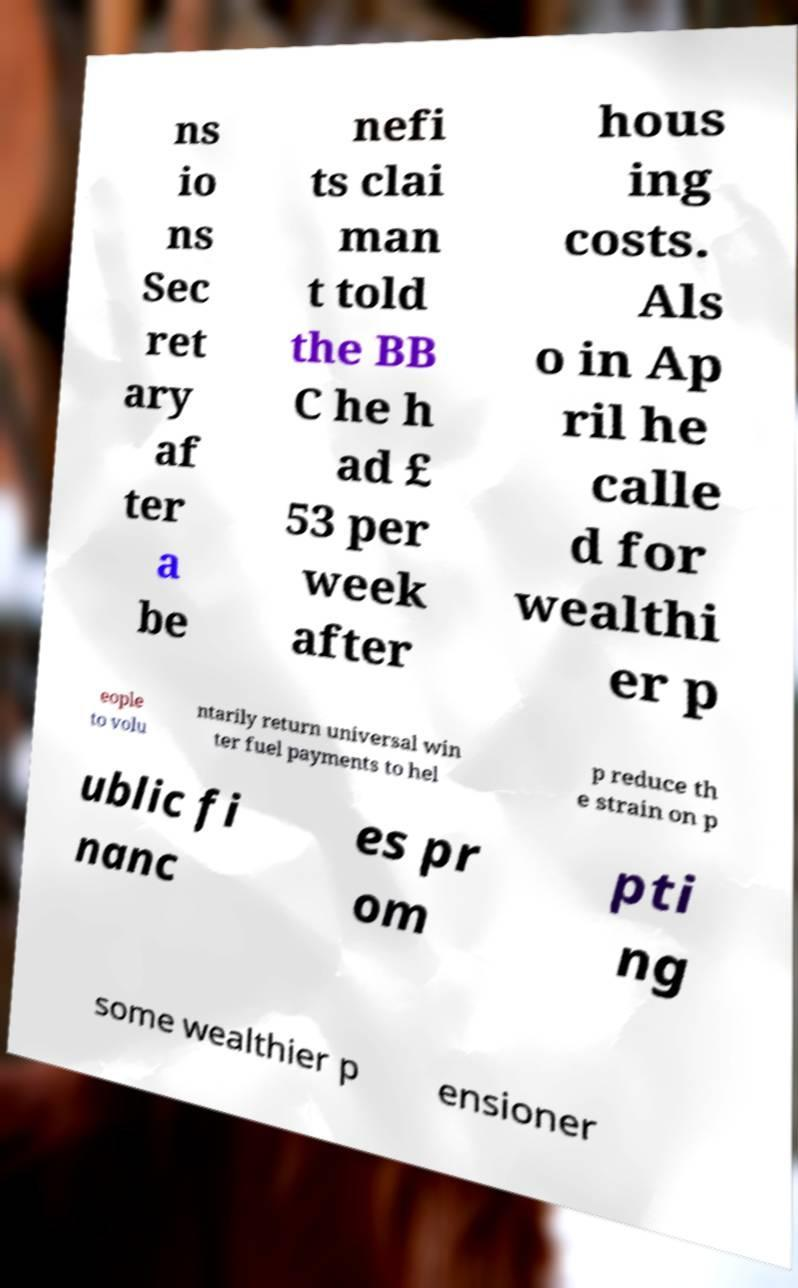I need the written content from this picture converted into text. Can you do that? ns io ns Sec ret ary af ter a be nefi ts clai man t told the BB C he h ad £ 53 per week after hous ing costs. Als o in Ap ril he calle d for wealthi er p eople to volu ntarily return universal win ter fuel payments to hel p reduce th e strain on p ublic fi nanc es pr om pti ng some wealthier p ensioner 